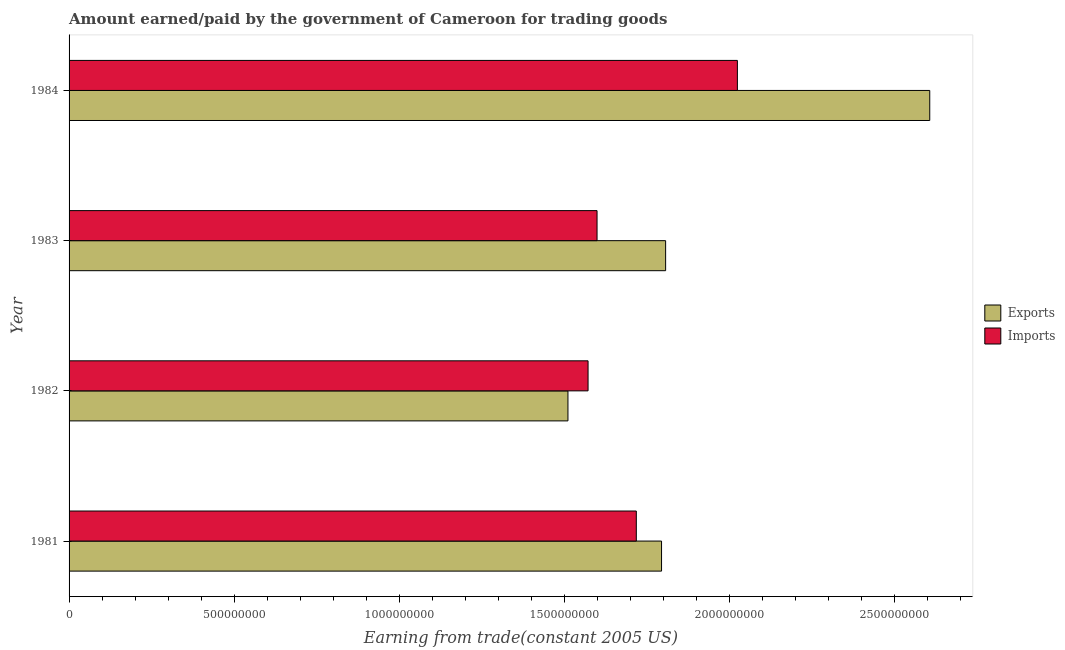How many different coloured bars are there?
Offer a terse response. 2. Are the number of bars per tick equal to the number of legend labels?
Make the answer very short. Yes. How many bars are there on the 2nd tick from the top?
Offer a very short reply. 2. What is the label of the 3rd group of bars from the top?
Your answer should be very brief. 1982. In how many cases, is the number of bars for a given year not equal to the number of legend labels?
Your response must be concise. 0. What is the amount paid for imports in 1983?
Your answer should be very brief. 1.60e+09. Across all years, what is the maximum amount earned from exports?
Your answer should be very brief. 2.61e+09. Across all years, what is the minimum amount earned from exports?
Your answer should be very brief. 1.51e+09. In which year was the amount earned from exports maximum?
Provide a short and direct response. 1984. What is the total amount earned from exports in the graph?
Offer a very short reply. 7.72e+09. What is the difference between the amount earned from exports in 1981 and that in 1984?
Your answer should be very brief. -8.12e+08. What is the difference between the amount earned from exports in 1984 and the amount paid for imports in 1983?
Offer a terse response. 1.01e+09. What is the average amount earned from exports per year?
Ensure brevity in your answer.  1.93e+09. In the year 1984, what is the difference between the amount paid for imports and amount earned from exports?
Provide a short and direct response. -5.82e+08. What is the ratio of the amount paid for imports in 1981 to that in 1983?
Your answer should be very brief. 1.07. Is the difference between the amount earned from exports in 1982 and 1983 greater than the difference between the amount paid for imports in 1982 and 1983?
Your response must be concise. No. What is the difference between the highest and the second highest amount earned from exports?
Your response must be concise. 8.00e+08. What is the difference between the highest and the lowest amount earned from exports?
Offer a terse response. 1.10e+09. In how many years, is the amount paid for imports greater than the average amount paid for imports taken over all years?
Give a very brief answer. 1. Is the sum of the amount earned from exports in 1981 and 1982 greater than the maximum amount paid for imports across all years?
Offer a terse response. Yes. What does the 1st bar from the top in 1982 represents?
Offer a very short reply. Imports. What does the 2nd bar from the bottom in 1983 represents?
Your answer should be very brief. Imports. How many bars are there?
Your answer should be very brief. 8. How many years are there in the graph?
Make the answer very short. 4. Does the graph contain any zero values?
Make the answer very short. No. Does the graph contain grids?
Give a very brief answer. No. What is the title of the graph?
Ensure brevity in your answer.  Amount earned/paid by the government of Cameroon for trading goods. Does "GDP per capita" appear as one of the legend labels in the graph?
Offer a very short reply. No. What is the label or title of the X-axis?
Keep it short and to the point. Earning from trade(constant 2005 US). What is the Earning from trade(constant 2005 US) of Exports in 1981?
Ensure brevity in your answer.  1.79e+09. What is the Earning from trade(constant 2005 US) in Imports in 1981?
Offer a very short reply. 1.72e+09. What is the Earning from trade(constant 2005 US) in Exports in 1982?
Ensure brevity in your answer.  1.51e+09. What is the Earning from trade(constant 2005 US) of Imports in 1982?
Provide a succinct answer. 1.57e+09. What is the Earning from trade(constant 2005 US) of Exports in 1983?
Your answer should be compact. 1.81e+09. What is the Earning from trade(constant 2005 US) in Imports in 1983?
Keep it short and to the point. 1.60e+09. What is the Earning from trade(constant 2005 US) in Exports in 1984?
Your response must be concise. 2.61e+09. What is the Earning from trade(constant 2005 US) in Imports in 1984?
Your response must be concise. 2.02e+09. Across all years, what is the maximum Earning from trade(constant 2005 US) in Exports?
Your answer should be compact. 2.61e+09. Across all years, what is the maximum Earning from trade(constant 2005 US) of Imports?
Offer a very short reply. 2.02e+09. Across all years, what is the minimum Earning from trade(constant 2005 US) of Exports?
Provide a short and direct response. 1.51e+09. Across all years, what is the minimum Earning from trade(constant 2005 US) in Imports?
Offer a terse response. 1.57e+09. What is the total Earning from trade(constant 2005 US) in Exports in the graph?
Your answer should be very brief. 7.72e+09. What is the total Earning from trade(constant 2005 US) in Imports in the graph?
Ensure brevity in your answer.  6.91e+09. What is the difference between the Earning from trade(constant 2005 US) of Exports in 1981 and that in 1982?
Offer a terse response. 2.83e+08. What is the difference between the Earning from trade(constant 2005 US) of Imports in 1981 and that in 1982?
Your response must be concise. 1.46e+08. What is the difference between the Earning from trade(constant 2005 US) of Exports in 1981 and that in 1983?
Your response must be concise. -1.24e+07. What is the difference between the Earning from trade(constant 2005 US) in Imports in 1981 and that in 1983?
Give a very brief answer. 1.19e+08. What is the difference between the Earning from trade(constant 2005 US) of Exports in 1981 and that in 1984?
Ensure brevity in your answer.  -8.12e+08. What is the difference between the Earning from trade(constant 2005 US) of Imports in 1981 and that in 1984?
Offer a terse response. -3.06e+08. What is the difference between the Earning from trade(constant 2005 US) in Exports in 1982 and that in 1983?
Offer a terse response. -2.96e+08. What is the difference between the Earning from trade(constant 2005 US) of Imports in 1982 and that in 1983?
Keep it short and to the point. -2.72e+07. What is the difference between the Earning from trade(constant 2005 US) of Exports in 1982 and that in 1984?
Provide a succinct answer. -1.10e+09. What is the difference between the Earning from trade(constant 2005 US) of Imports in 1982 and that in 1984?
Keep it short and to the point. -4.52e+08. What is the difference between the Earning from trade(constant 2005 US) in Exports in 1983 and that in 1984?
Offer a terse response. -8.00e+08. What is the difference between the Earning from trade(constant 2005 US) in Imports in 1983 and that in 1984?
Ensure brevity in your answer.  -4.25e+08. What is the difference between the Earning from trade(constant 2005 US) of Exports in 1981 and the Earning from trade(constant 2005 US) of Imports in 1982?
Offer a very short reply. 2.22e+08. What is the difference between the Earning from trade(constant 2005 US) in Exports in 1981 and the Earning from trade(constant 2005 US) in Imports in 1983?
Offer a very short reply. 1.95e+08. What is the difference between the Earning from trade(constant 2005 US) in Exports in 1981 and the Earning from trade(constant 2005 US) in Imports in 1984?
Give a very brief answer. -2.30e+08. What is the difference between the Earning from trade(constant 2005 US) in Exports in 1982 and the Earning from trade(constant 2005 US) in Imports in 1983?
Offer a terse response. -8.81e+07. What is the difference between the Earning from trade(constant 2005 US) of Exports in 1982 and the Earning from trade(constant 2005 US) of Imports in 1984?
Provide a succinct answer. -5.13e+08. What is the difference between the Earning from trade(constant 2005 US) in Exports in 1983 and the Earning from trade(constant 2005 US) in Imports in 1984?
Provide a short and direct response. -2.17e+08. What is the average Earning from trade(constant 2005 US) of Exports per year?
Provide a succinct answer. 1.93e+09. What is the average Earning from trade(constant 2005 US) of Imports per year?
Make the answer very short. 1.73e+09. In the year 1981, what is the difference between the Earning from trade(constant 2005 US) of Exports and Earning from trade(constant 2005 US) of Imports?
Keep it short and to the point. 7.64e+07. In the year 1982, what is the difference between the Earning from trade(constant 2005 US) of Exports and Earning from trade(constant 2005 US) of Imports?
Your answer should be very brief. -6.09e+07. In the year 1983, what is the difference between the Earning from trade(constant 2005 US) in Exports and Earning from trade(constant 2005 US) in Imports?
Provide a succinct answer. 2.08e+08. In the year 1984, what is the difference between the Earning from trade(constant 2005 US) of Exports and Earning from trade(constant 2005 US) of Imports?
Your answer should be very brief. 5.82e+08. What is the ratio of the Earning from trade(constant 2005 US) of Exports in 1981 to that in 1982?
Your answer should be very brief. 1.19. What is the ratio of the Earning from trade(constant 2005 US) in Imports in 1981 to that in 1982?
Your answer should be compact. 1.09. What is the ratio of the Earning from trade(constant 2005 US) in Exports in 1981 to that in 1983?
Your answer should be very brief. 0.99. What is the ratio of the Earning from trade(constant 2005 US) of Imports in 1981 to that in 1983?
Give a very brief answer. 1.07. What is the ratio of the Earning from trade(constant 2005 US) of Exports in 1981 to that in 1984?
Offer a very short reply. 0.69. What is the ratio of the Earning from trade(constant 2005 US) in Imports in 1981 to that in 1984?
Keep it short and to the point. 0.85. What is the ratio of the Earning from trade(constant 2005 US) of Exports in 1982 to that in 1983?
Ensure brevity in your answer.  0.84. What is the ratio of the Earning from trade(constant 2005 US) of Imports in 1982 to that in 1983?
Make the answer very short. 0.98. What is the ratio of the Earning from trade(constant 2005 US) of Exports in 1982 to that in 1984?
Offer a very short reply. 0.58. What is the ratio of the Earning from trade(constant 2005 US) of Imports in 1982 to that in 1984?
Offer a very short reply. 0.78. What is the ratio of the Earning from trade(constant 2005 US) in Exports in 1983 to that in 1984?
Your response must be concise. 0.69. What is the ratio of the Earning from trade(constant 2005 US) of Imports in 1983 to that in 1984?
Make the answer very short. 0.79. What is the difference between the highest and the second highest Earning from trade(constant 2005 US) in Exports?
Keep it short and to the point. 8.00e+08. What is the difference between the highest and the second highest Earning from trade(constant 2005 US) of Imports?
Your response must be concise. 3.06e+08. What is the difference between the highest and the lowest Earning from trade(constant 2005 US) of Exports?
Your response must be concise. 1.10e+09. What is the difference between the highest and the lowest Earning from trade(constant 2005 US) in Imports?
Provide a succinct answer. 4.52e+08. 